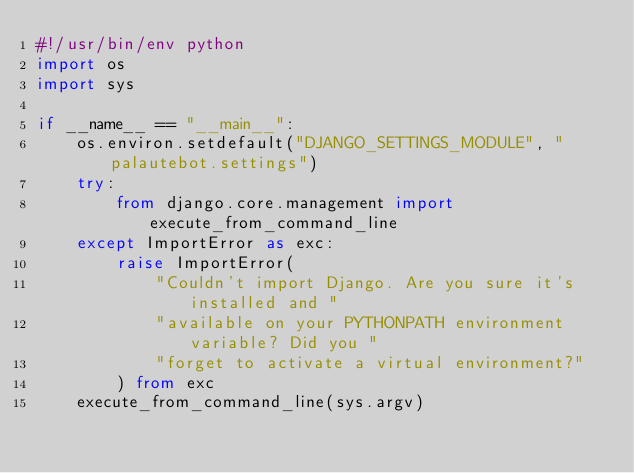Convert code to text. <code><loc_0><loc_0><loc_500><loc_500><_Python_>#!/usr/bin/env python
import os
import sys

if __name__ == "__main__":
    os.environ.setdefault("DJANGO_SETTINGS_MODULE", "palautebot.settings")
    try:
        from django.core.management import execute_from_command_line
    except ImportError as exc:
        raise ImportError(
            "Couldn't import Django. Are you sure it's installed and "
            "available on your PYTHONPATH environment variable? Did you "
            "forget to activate a virtual environment?"
        ) from exc
    execute_from_command_line(sys.argv)
</code> 